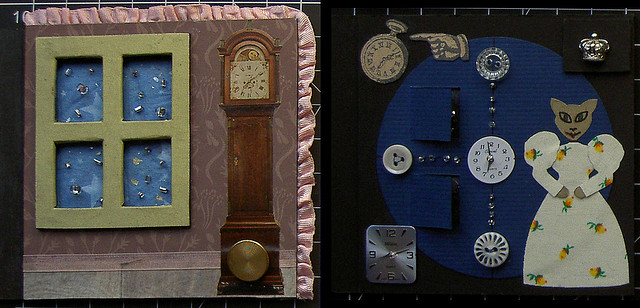Identify and read out the text in this image. 12 11 10 9 8 7 6 5 4 3 2 1 12 3 9 